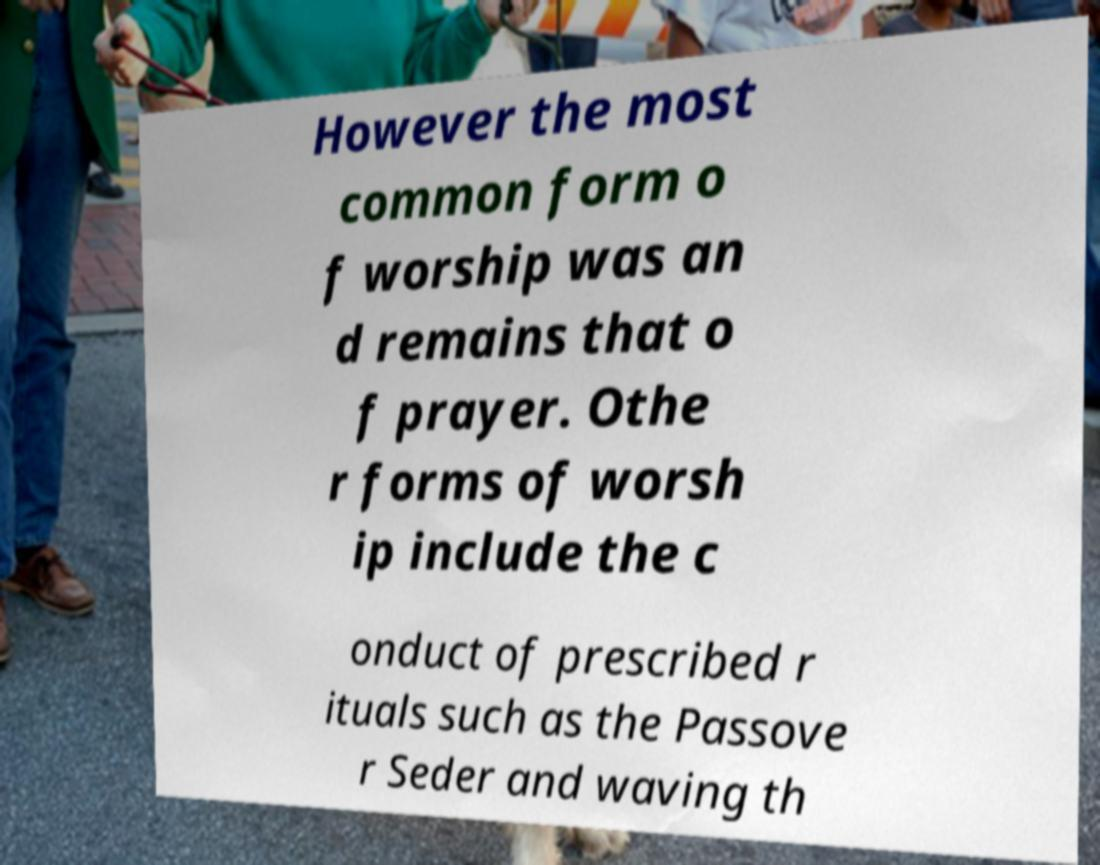There's text embedded in this image that I need extracted. Can you transcribe it verbatim? However the most common form o f worship was an d remains that o f prayer. Othe r forms of worsh ip include the c onduct of prescribed r ituals such as the Passove r Seder and waving th 